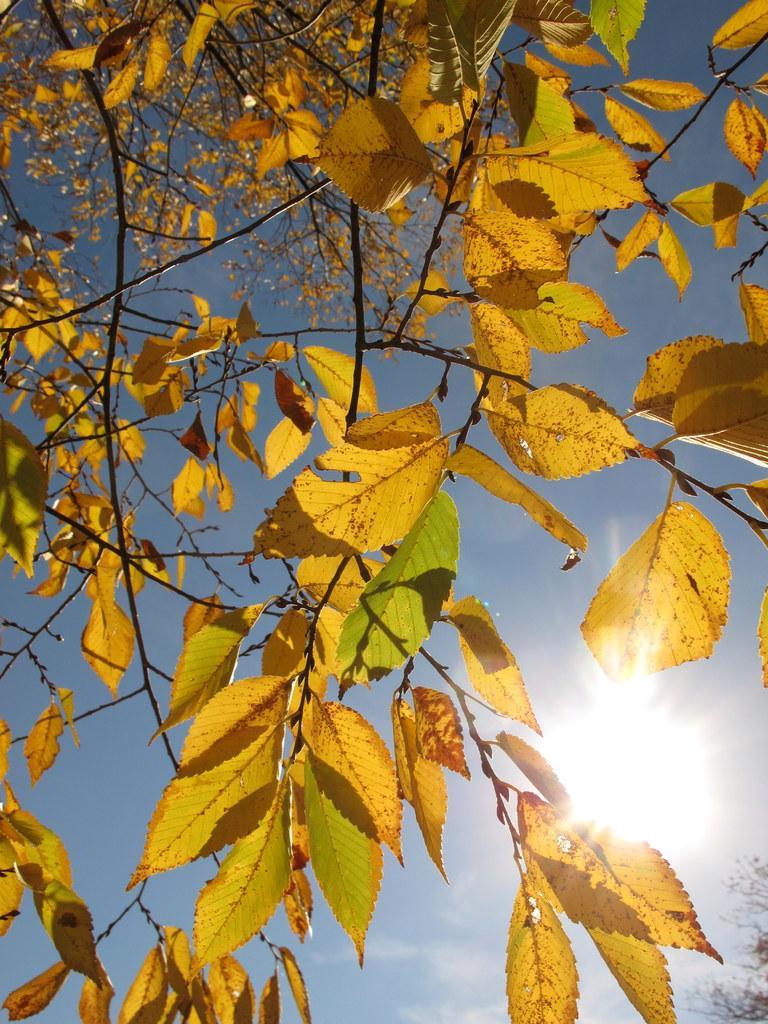Please provide a concise description of this image. In this image there are leaves, in the background there is a sky and a sun. 